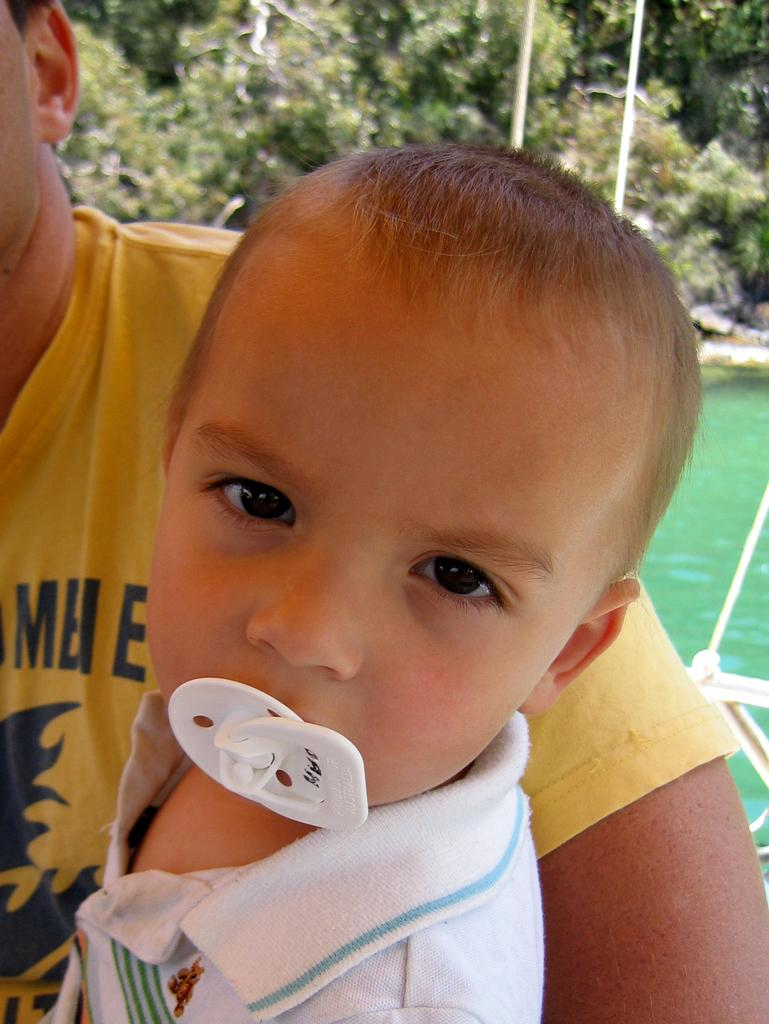What is happening in the image involving a person and a child? There is a person carrying a child in the image. What is the child doing while being carried? The child is holding an object in their mouth. What can be seen in the background of the image? There is water and trees visible in the background of the image. What news is being discussed by the person and child in the image? There is no indication of any news being discussed in the image; it simply shows a person carrying a child with an object in their mouth. 